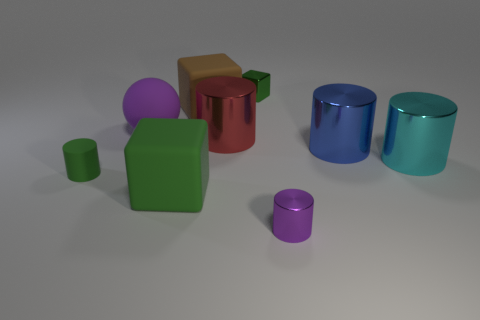Subtract all purple cylinders. How many cylinders are left? 4 Subtract all matte cylinders. How many cylinders are left? 4 Subtract all red cylinders. Subtract all cyan balls. How many cylinders are left? 4 Add 1 shiny cylinders. How many objects exist? 10 Subtract all balls. How many objects are left? 8 Add 5 big yellow metal cylinders. How many big yellow metal cylinders exist? 5 Subtract 1 green cylinders. How many objects are left? 8 Subtract all purple matte spheres. Subtract all large green matte things. How many objects are left? 7 Add 7 small matte things. How many small matte things are left? 8 